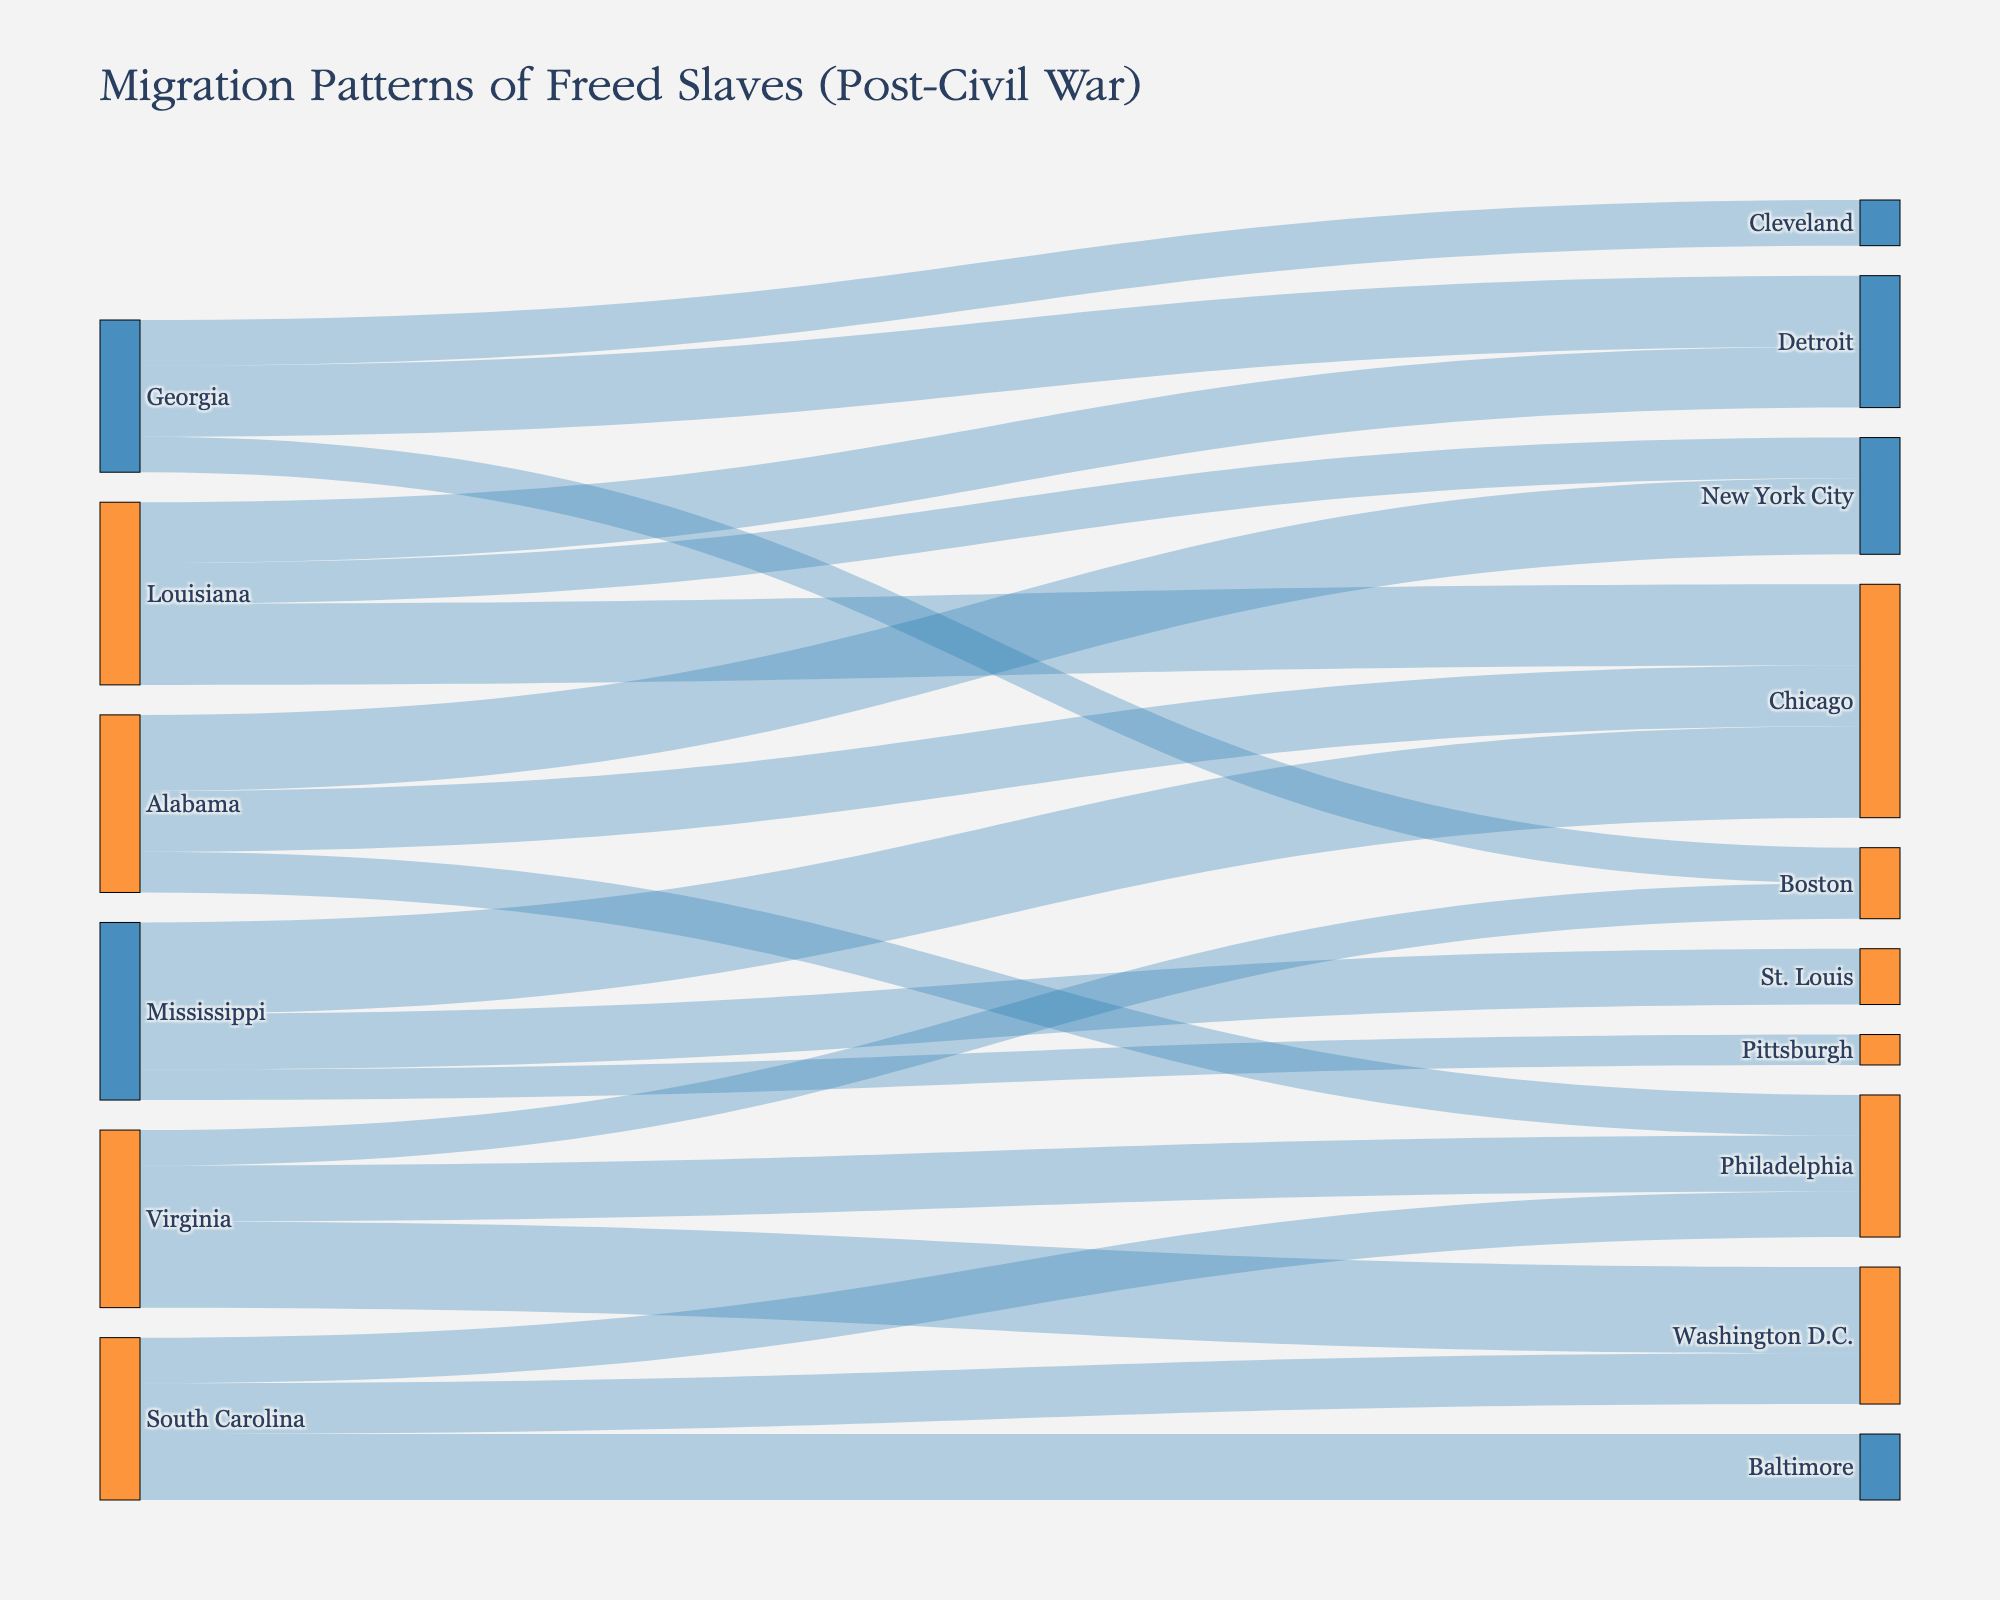What is the title of the figure? The title is located at the top of the figure and represents the main idea or the main subject of the data visualized. Here it is clearly written.
Answer: Migration Patterns of Freed Slaves (Post-Civil War) How many people migrated from Georgia to Boston? To find this, look for the link (line) connecting Georgia to Boston and read the numerical value indicated for that link.
Answer: 7000 Which Northern city received the most migrants from Alabama? Compare the values of the links flowing from Alabama to various Northern cities (New York City, Chicago, Philadelphia) and identify the highest value.
Answer: New York City How does the migration to Chicago from Alabama compare to that from Mississippi? Identify the values of the links from Alabama to Chicago and from Mississippi to Chicago, then compare these values.
Answer: Mississippi sent 6000 more migrants than Alabama (Alabama: 12000, Mississippi: 18000) What is the total number of people who migrated from Virginia? Sum the values of all links originating from Virginia to various cities (Washington D.C., Philadelphia, Boston) to find the total number.
Answer: 35000 Which Southern state had the highest number of total migrants to Northern cities? Sum the migrant values for each Southern state individually and compare these sums to determine the one with the highest total.
Answer: Mississippi (36000) In which Northern city do you observe the highest cumulative number of migrants from different Southern states? Sum the incoming migration values for each Northern city separately and identify the city with the highest total.
Answer: Chicago (56000) How many more people migrated from Louisiana to Chicago than to New York City? Subtract the number of migrants from Louisiana to New York City from those to Chicago to determine the difference.
Answer: 8000 (16000 - 8000) Which cities received migrants from South Carolina? Identify and list all the target cities indicated for migrations originating from South Carolina. These are represented by the link connections from South Carolina.
Answer: Baltimore, Washington D.C., Philadelphia What is the difference in migration numbers between the largest and smallest flows from Georgia? Identify the largest and smallest values of migration flows from Georgia, and subtract the smallest value from the largest.
Answer: 7000 (14000 - 7000) 